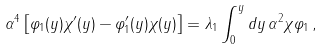<formula> <loc_0><loc_0><loc_500><loc_500>\alpha ^ { 4 } \left [ \varphi _ { 1 } ( y ) \chi ^ { \prime } ( y ) - \varphi ^ { \prime } _ { 1 } ( y ) \chi ( y ) \right ] = \lambda _ { 1 } \int _ { 0 } ^ { y } d y \, \alpha ^ { 2 } \chi \varphi _ { 1 } \, ,</formula> 